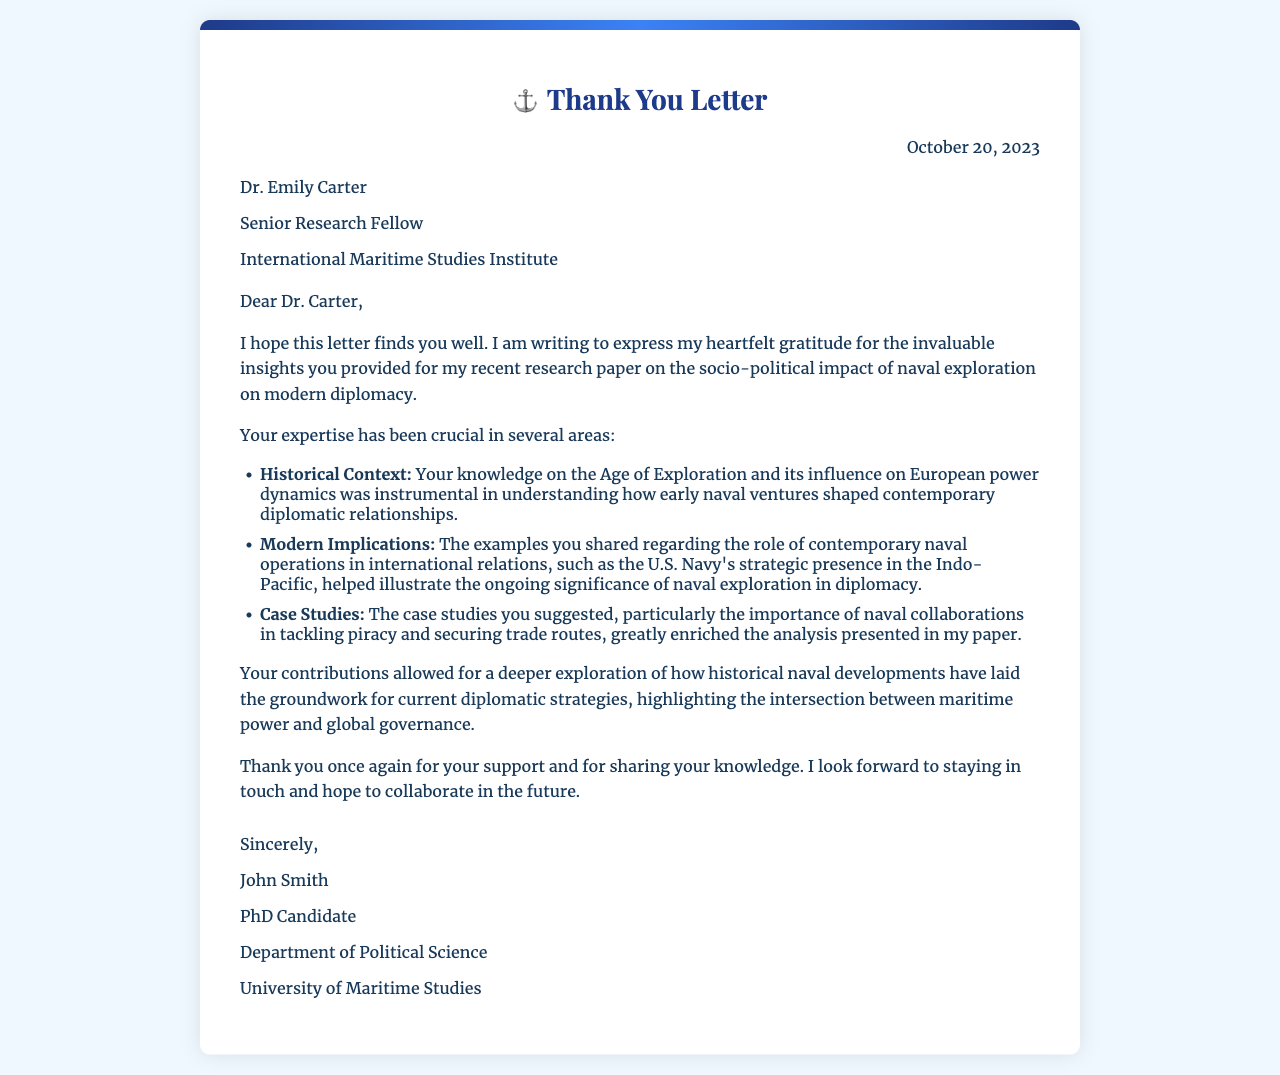What is the date of the letter? The date of the letter is clearly stated at the top right section of the document.
Answer: October 20, 2023 Who is the recipient of the letter? The recipient's name and title are provided in the document after the date.
Answer: Dr. Emily Carter What is Dr. Emily Carter's role? Dr. Carter's professional title is listed directly following her name.
Answer: Senior Research Fellow Which university is John Smith affiliated with? The affiliation of John Smith is mentioned in the signature section of the letter.
Answer: University of Maritime Studies What is one historical context mentioned? The document lists specific areas where Dr. Carter's insight was impactful, one of which is highlighted for its importance regarding naval exploration.
Answer: Age of Exploration Why is contemporary naval operations significant? The letter explains the context in which contemporary naval operations contribute to modern diplomacy.
Answer: International relations What kind of collaborations did the case studies focus on? The document directly refers to the main focus of the proposed case studies related to naval operations.
Answer: Tackling piracy and securing trade routes What is the main purpose of this letter? The purpose of the letter is implicitly clear through the opening statements and overall tone of gratitude expressed by the sender.
Answer: Express gratitude 